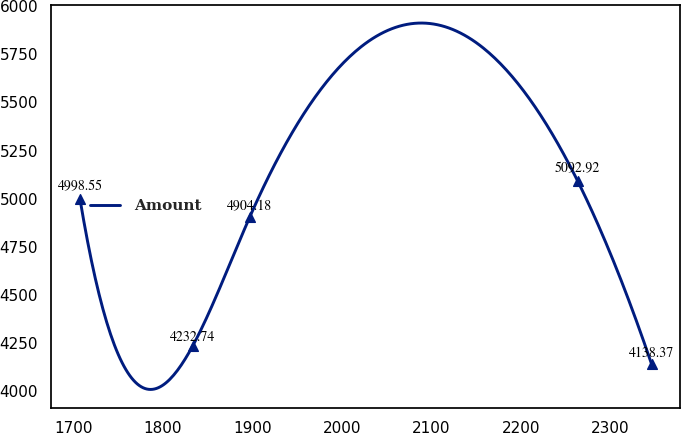Convert chart. <chart><loc_0><loc_0><loc_500><loc_500><line_chart><ecel><fcel>Amount<nl><fcel>1707.61<fcel>4998.55<nl><fcel>1833.42<fcel>4232.74<nl><fcel>1897.28<fcel>4904.18<nl><fcel>2263.44<fcel>5092.92<nl><fcel>2346.24<fcel>4138.37<nl></chart> 